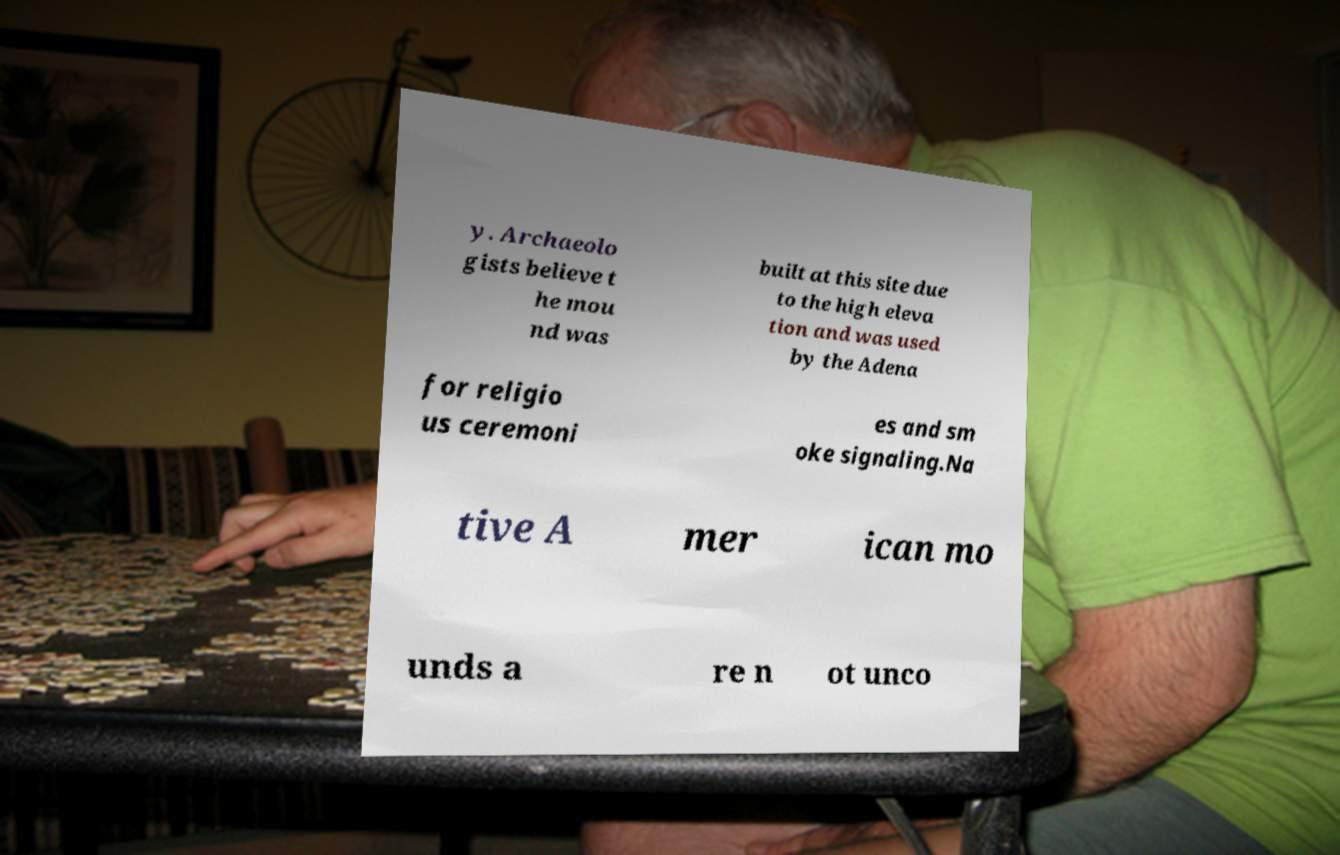I need the written content from this picture converted into text. Can you do that? y. Archaeolo gists believe t he mou nd was built at this site due to the high eleva tion and was used by the Adena for religio us ceremoni es and sm oke signaling.Na tive A mer ican mo unds a re n ot unco 